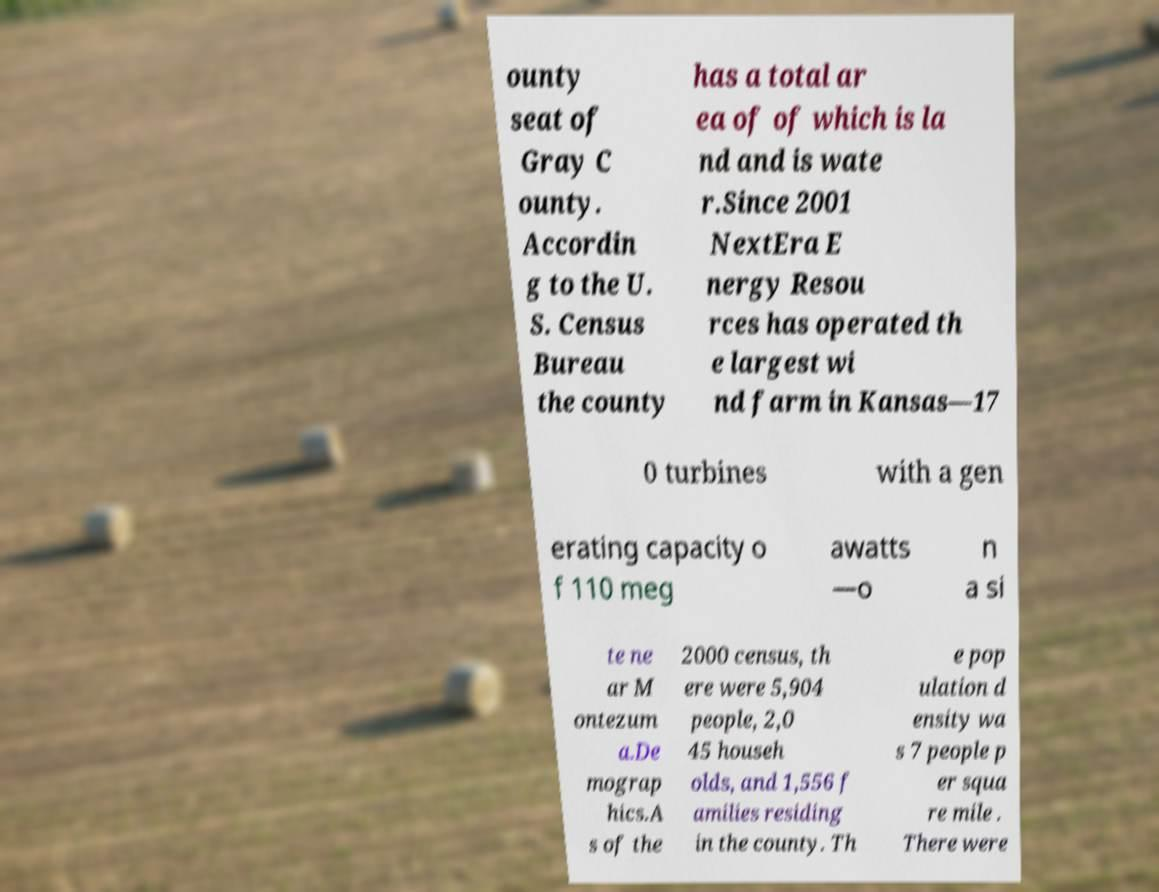There's text embedded in this image that I need extracted. Can you transcribe it verbatim? ounty seat of Gray C ounty. Accordin g to the U. S. Census Bureau the county has a total ar ea of of which is la nd and is wate r.Since 2001 NextEra E nergy Resou rces has operated th e largest wi nd farm in Kansas—17 0 turbines with a gen erating capacity o f 110 meg awatts —o n a si te ne ar M ontezum a.De mograp hics.A s of the 2000 census, th ere were 5,904 people, 2,0 45 househ olds, and 1,556 f amilies residing in the county. Th e pop ulation d ensity wa s 7 people p er squa re mile . There were 